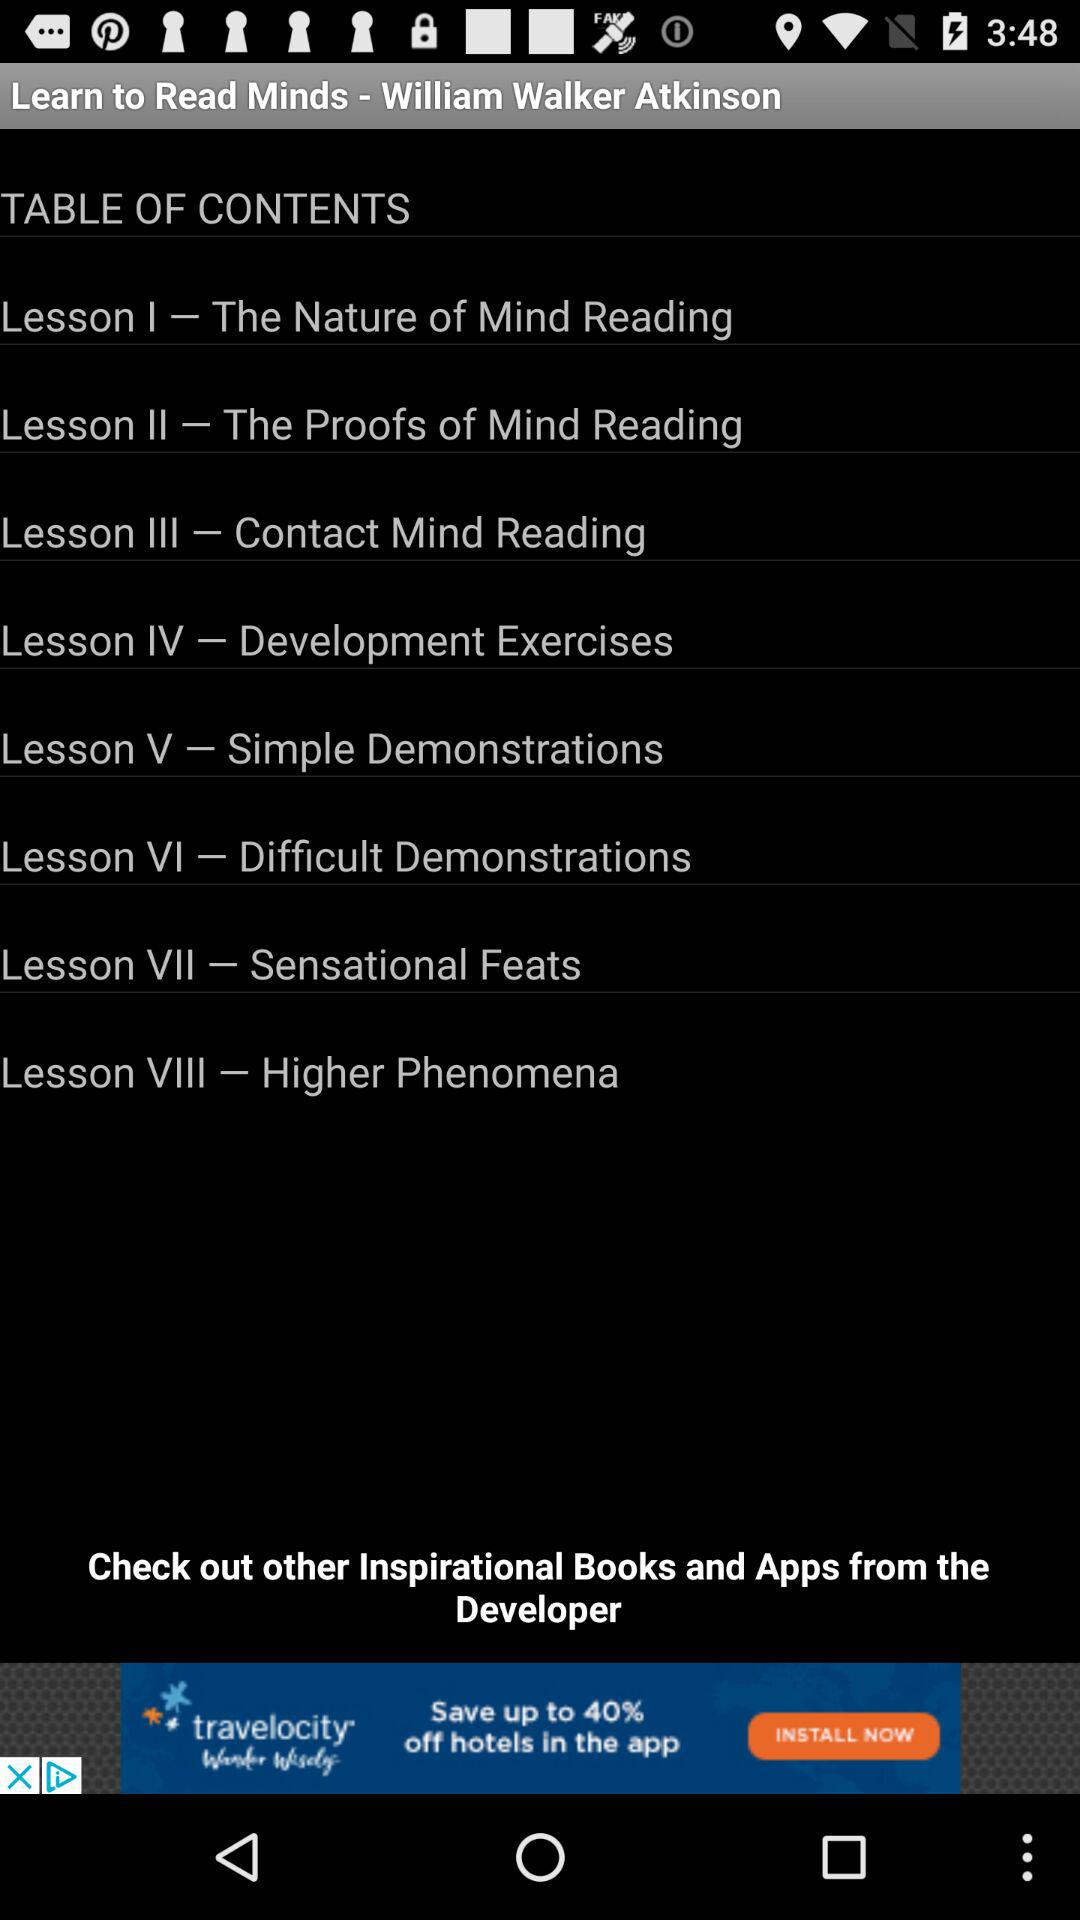What is the title of "Lesson I"? The title is "The Nature of Mind Reading". 